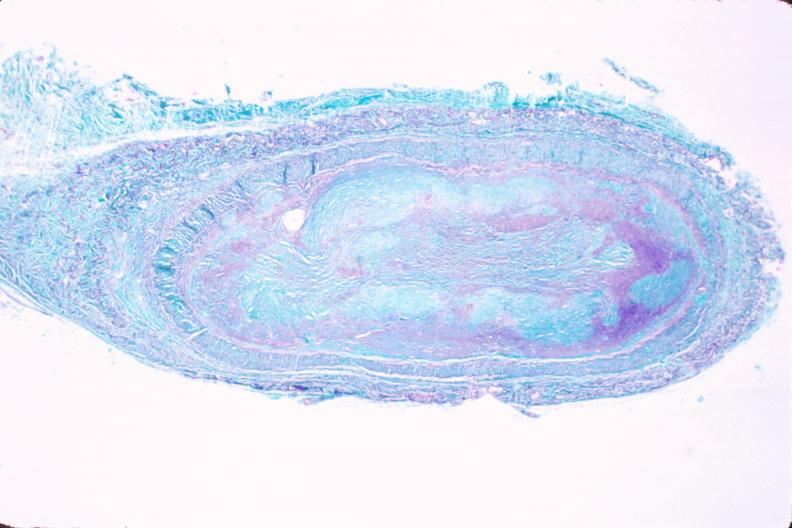s this typical lesion present?
Answer the question using a single word or phrase. No 